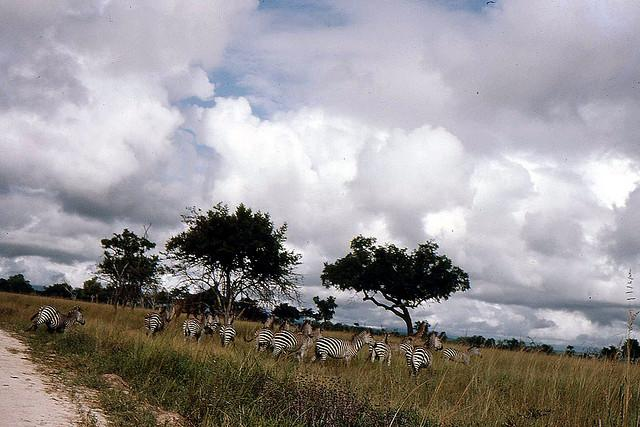The clouds in the sky depict that a is coming? Please explain your reasoning. storm. Many zebras standing in a grassy field. there are many grey clouds rolling in above them. 